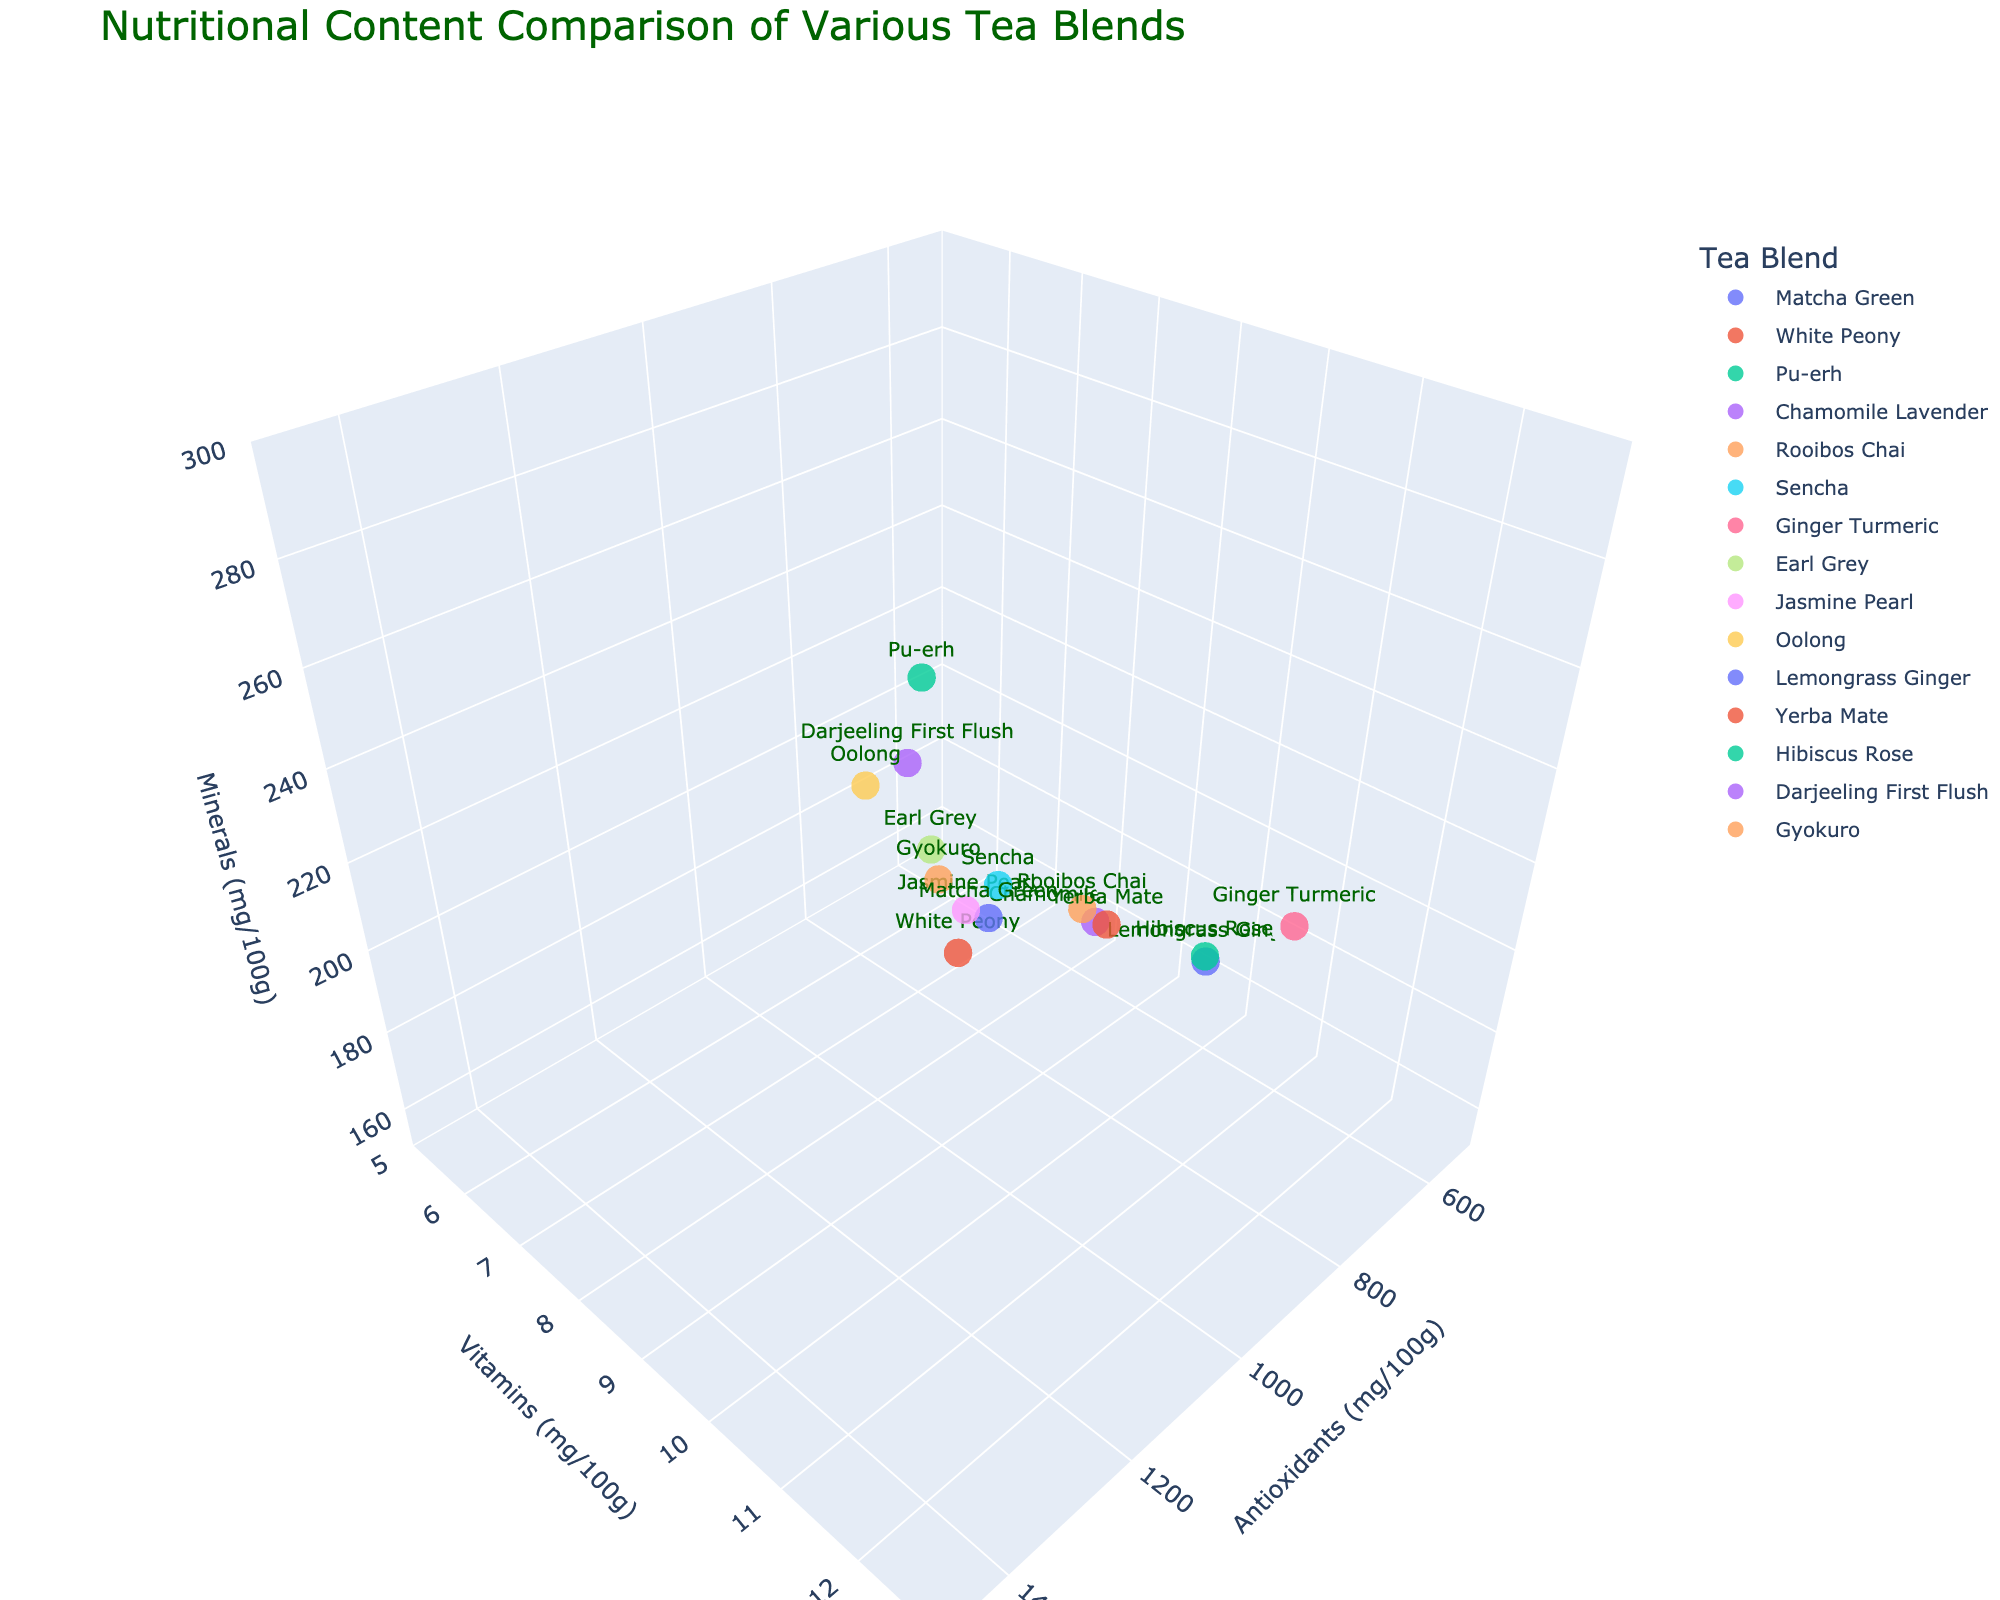What is the title of the plot? The title of a plot is usually located at the top. For this plot, the title is clearly displayed at the top center in a dark green color.
Answer: "Nutritional Content Comparison of Various Tea Blends" How many tea blends are depicted in the figure? Each data point represents a tea blend, and the plot has a legend showing the names of the tea blends. Counting these, we find 15 tea blends.
Answer: 15 Which tea blend has the highest antioxidant content? Looking at the x-axis, which represents antioxidants, the data point farthest to the right corresponds to "Matcha Green" with the highest value of 1384 mg/100g.
Answer: Matcha Green What is the vitamin content of the tea blend with the highest mineral content? The z-axis represents minerals, and the point highest along this axis is "Matcha Green" with 275 mg/100g. The corresponding y-axis value (vitamins) for "Matcha Green" is 12.5 mg/100g.
Answer: 12.5 mg/100g Which tea blends have a vitamin content greater than 10 mg/100g? For vitamin content greater than 10 mg/100g, look at points above this value on the y-axis. The tea blends are Ginger Turmeric, Yerba Mate, Hibiscus Rose, and Gyokuro.
Answer: Ginger Turmeric, Yerba Mate, Hibiscus Rose, Gyokuro What is the average mineral content of Matcha Green, Gyokuro, and Yerba Mate? Identify the mineral content for these blends: Matcha Green (275 mg/100g), Gyokuro (260 mg/100g), and Yerba Mate (245 mg/100g). Calculate the average: (275 + 260 + 245) / 3 = 260 mg/100g.
Answer: 260 mg/100g Which tea blend has the lowest antioxidants content and what is its value? The data point farthest to the left on the x-axis represents the lowest antioxidants. "Chamomile Lavender" has the lowest value at 520 mg/100g.
Answer: Chamomile Lavender, 520 mg/100g What is the range of mineral content for the tea blends presented? The highest mineral content is 275 mg/100g (Matcha Green) and the lowest is 155 mg/100g (Chamomile Lavender). Therefore, the range is 275 - 155 = 120 mg/100g.
Answer: 120 mg/100g Are there any tea blends that have both high antioxidants and high vitamins? Identify tea blends positioned towards the top right of the plot indicating high values in both categories. "Matcha Green" (1384 mg/100g antioxidants, 12.5 mg/100g vitamins) and "Yerba Mate" (1120 mg/100g antioxidants, 11.8 mg/100g vitamins) fit this criterion.
Answer: Yes, Matcha Green and Yerba Mate 